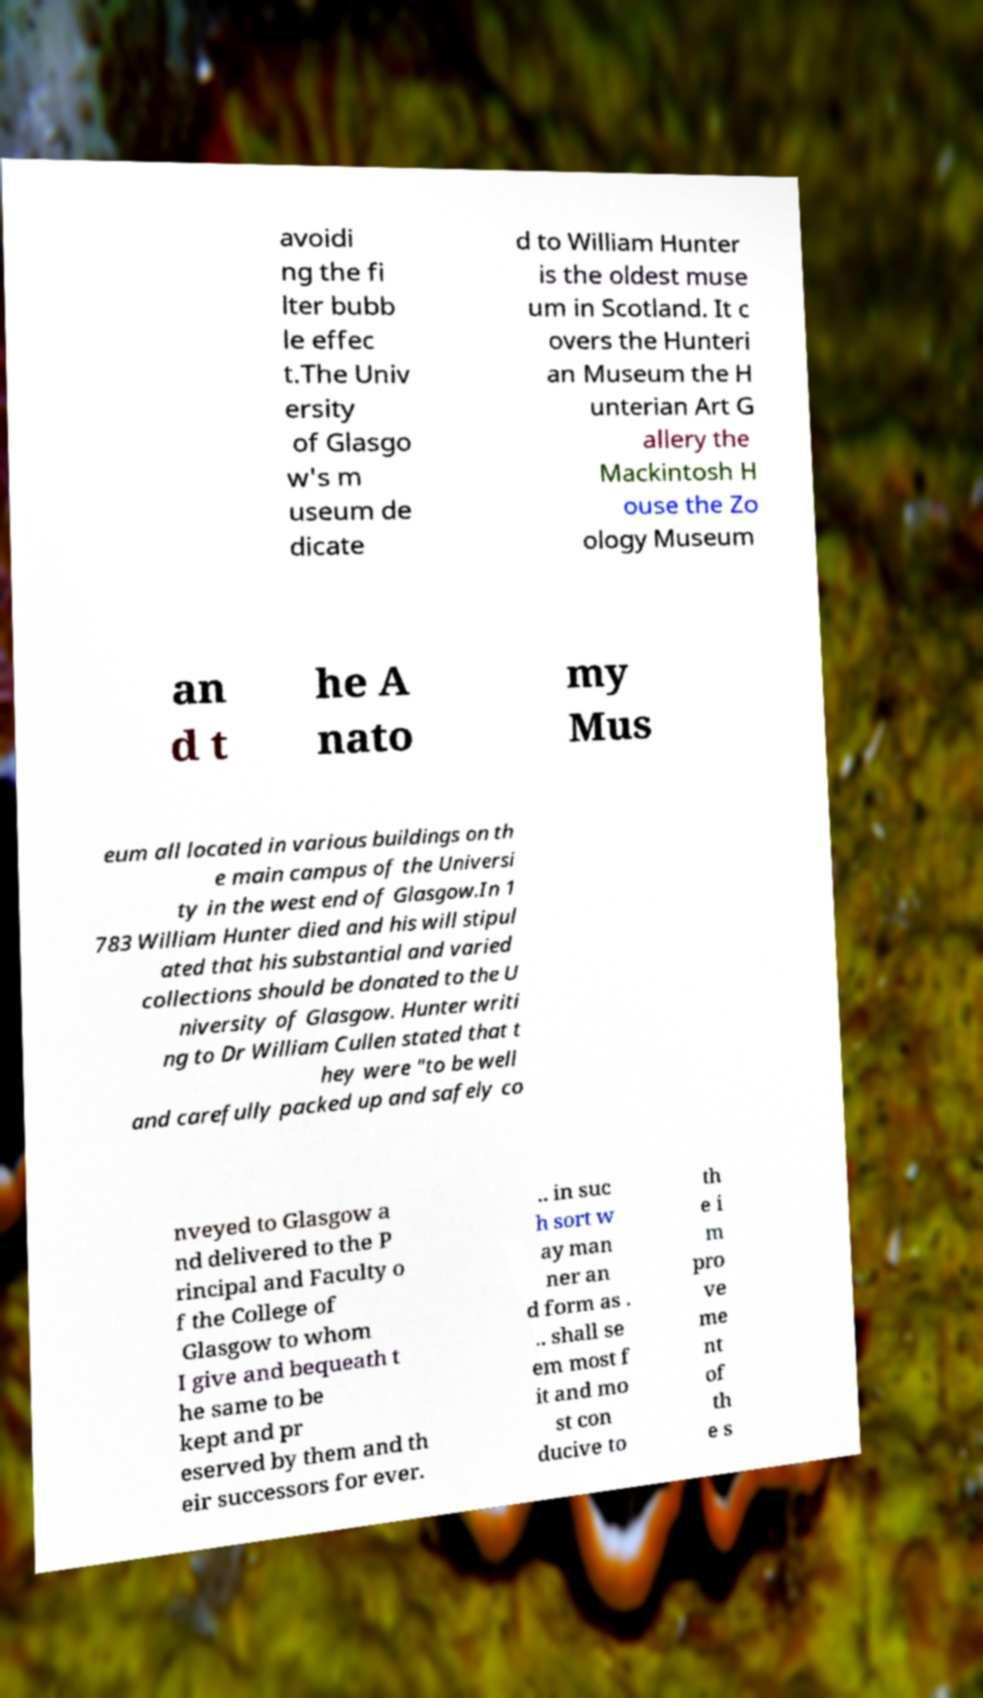I need the written content from this picture converted into text. Can you do that? avoidi ng the fi lter bubb le effec t.The Univ ersity of Glasgo w's m useum de dicate d to William Hunter is the oldest muse um in Scotland. It c overs the Hunteri an Museum the H unterian Art G allery the Mackintosh H ouse the Zo ology Museum an d t he A nato my Mus eum all located in various buildings on th e main campus of the Universi ty in the west end of Glasgow.In 1 783 William Hunter died and his will stipul ated that his substantial and varied collections should be donated to the U niversity of Glasgow. Hunter writi ng to Dr William Cullen stated that t hey were "to be well and carefully packed up and safely co nveyed to Glasgow a nd delivered to the P rincipal and Faculty o f the College of Glasgow to whom I give and bequeath t he same to be kept and pr eserved by them and th eir successors for ever. .. in suc h sort w ay man ner an d form as . .. shall se em most f it and mo st con ducive to th e i m pro ve me nt of th e s 